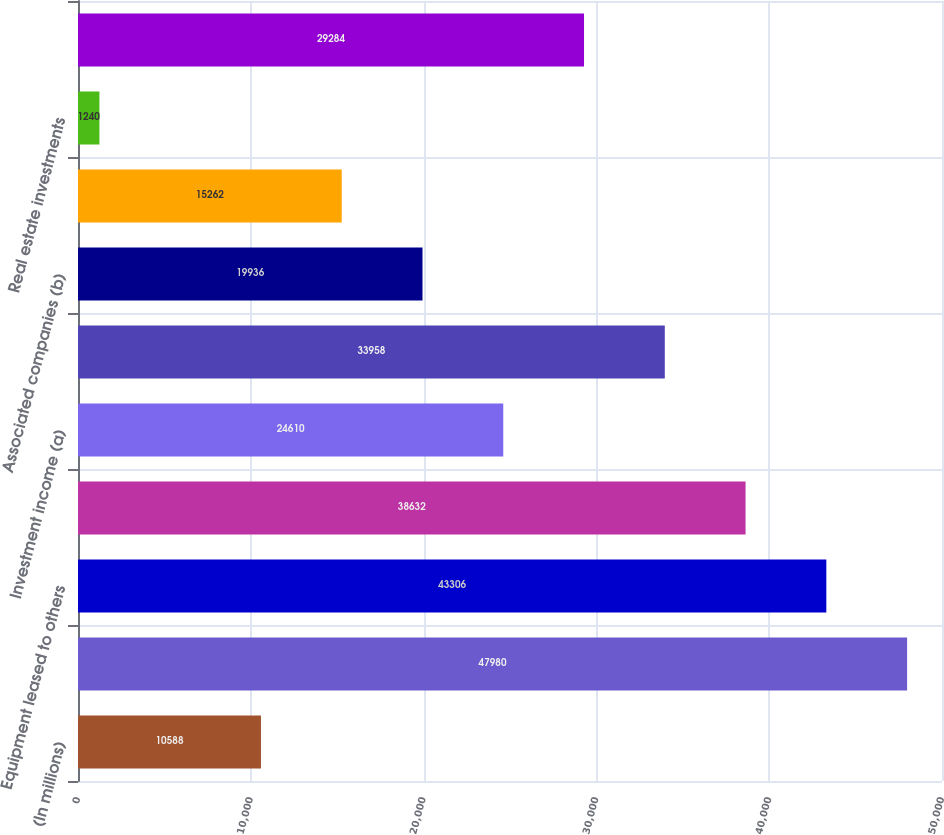<chart> <loc_0><loc_0><loc_500><loc_500><bar_chart><fcel>(In millions)<fcel>Interest on loans<fcel>Equipment leased to others<fcel>Fees<fcel>Investment income (a)<fcel>Financing leases<fcel>Associated companies (b)<fcel>Premiums earned by insurance<fcel>Real estate investments<fcel>Other items<nl><fcel>10588<fcel>47980<fcel>43306<fcel>38632<fcel>24610<fcel>33958<fcel>19936<fcel>15262<fcel>1240<fcel>29284<nl></chart> 